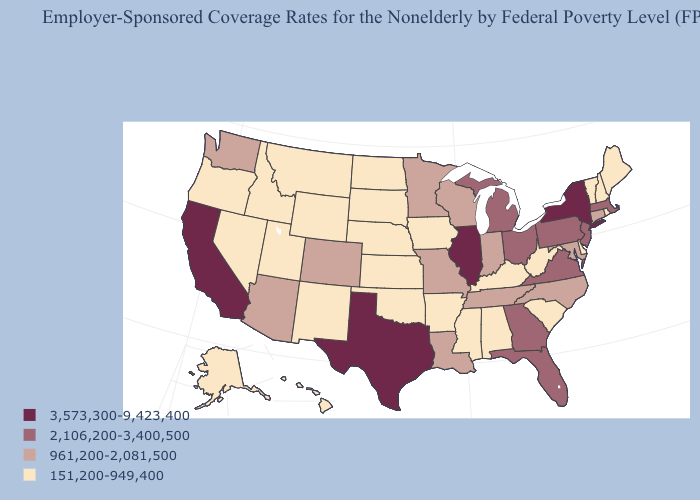Does the map have missing data?
Concise answer only. No. Name the states that have a value in the range 2,106,200-3,400,500?
Quick response, please. Florida, Georgia, Massachusetts, Michigan, New Jersey, Ohio, Pennsylvania, Virginia. Which states have the lowest value in the USA?
Quick response, please. Alabama, Alaska, Arkansas, Delaware, Hawaii, Idaho, Iowa, Kansas, Kentucky, Maine, Mississippi, Montana, Nebraska, Nevada, New Hampshire, New Mexico, North Dakota, Oklahoma, Oregon, Rhode Island, South Carolina, South Dakota, Utah, Vermont, West Virginia, Wyoming. Among the states that border Wyoming , does Nebraska have the lowest value?
Quick response, please. Yes. Does the map have missing data?
Write a very short answer. No. Does the first symbol in the legend represent the smallest category?
Be succinct. No. Name the states that have a value in the range 2,106,200-3,400,500?
Give a very brief answer. Florida, Georgia, Massachusetts, Michigan, New Jersey, Ohio, Pennsylvania, Virginia. Name the states that have a value in the range 961,200-2,081,500?
Write a very short answer. Arizona, Colorado, Connecticut, Indiana, Louisiana, Maryland, Minnesota, Missouri, North Carolina, Tennessee, Washington, Wisconsin. Does South Carolina have the same value as Pennsylvania?
Give a very brief answer. No. Is the legend a continuous bar?
Write a very short answer. No. What is the value of Arizona?
Quick response, please. 961,200-2,081,500. Does New Mexico have a higher value than Rhode Island?
Give a very brief answer. No. Among the states that border Massachusetts , does New Hampshire have the highest value?
Answer briefly. No. Which states have the lowest value in the USA?
Give a very brief answer. Alabama, Alaska, Arkansas, Delaware, Hawaii, Idaho, Iowa, Kansas, Kentucky, Maine, Mississippi, Montana, Nebraska, Nevada, New Hampshire, New Mexico, North Dakota, Oklahoma, Oregon, Rhode Island, South Carolina, South Dakota, Utah, Vermont, West Virginia, Wyoming. Name the states that have a value in the range 961,200-2,081,500?
Be succinct. Arizona, Colorado, Connecticut, Indiana, Louisiana, Maryland, Minnesota, Missouri, North Carolina, Tennessee, Washington, Wisconsin. 